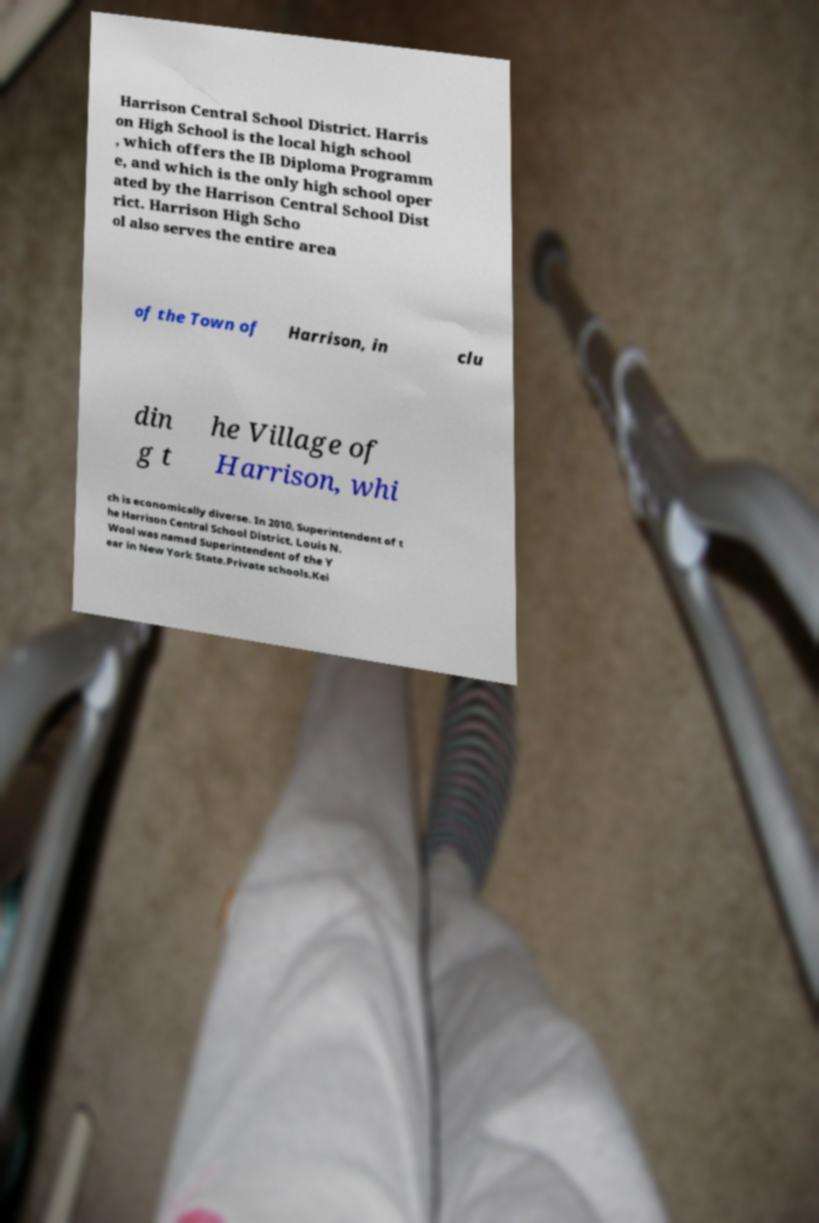Can you read and provide the text displayed in the image?This photo seems to have some interesting text. Can you extract and type it out for me? Harrison Central School District. Harris on High School is the local high school , which offers the IB Diploma Programm e, and which is the only high school oper ated by the Harrison Central School Dist rict. Harrison High Scho ol also serves the entire area of the Town of Harrison, in clu din g t he Village of Harrison, whi ch is economically diverse. In 2010, Superintendent of t he Harrison Central School District, Louis N. Wool was named Superintendent of the Y ear in New York State.Private schools.Kei 